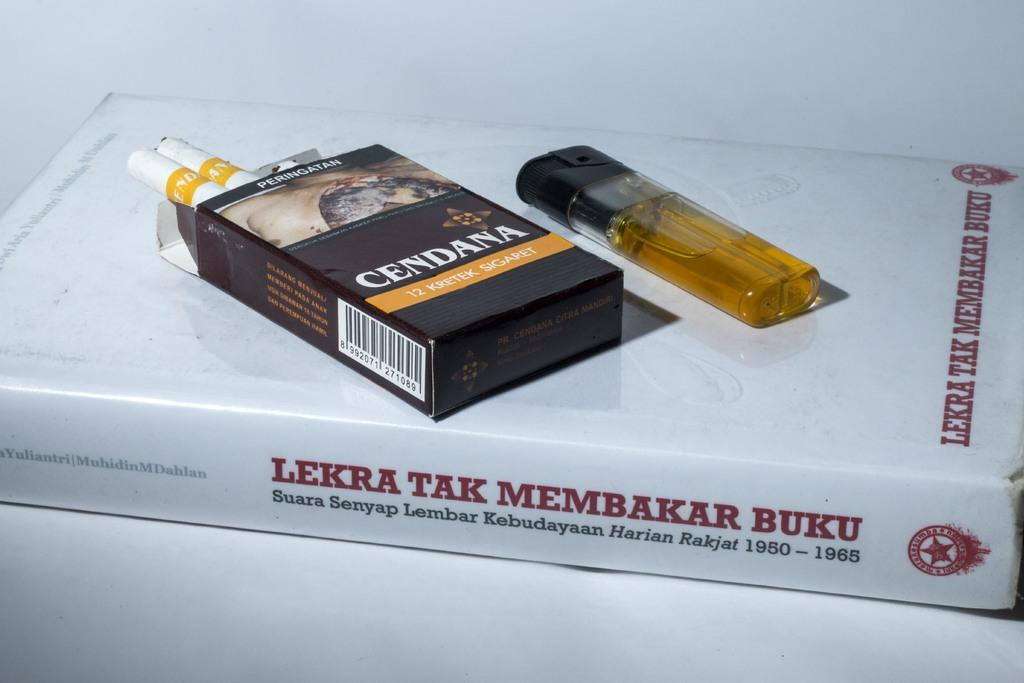<image>
Describe the image concisely. A pack of Cendana cigarettes sits next to a lighter, on top of a book 